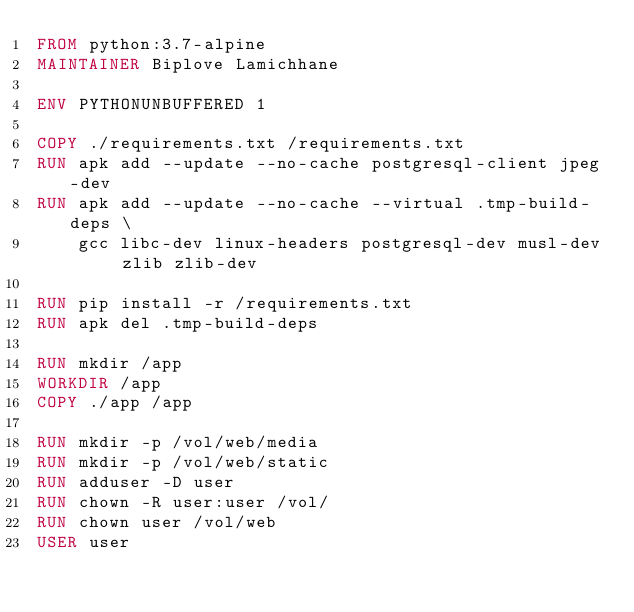<code> <loc_0><loc_0><loc_500><loc_500><_Dockerfile_>FROM python:3.7-alpine
MAINTAINER Biplove Lamichhane

ENV PYTHONUNBUFFERED 1

COPY ./requirements.txt /requirements.txt
RUN apk add --update --no-cache postgresql-client jpeg-dev
RUN apk add --update --no-cache --virtual .tmp-build-deps \
    gcc libc-dev linux-headers postgresql-dev musl-dev zlib zlib-dev

RUN pip install -r /requirements.txt
RUN apk del .tmp-build-deps

RUN mkdir /app
WORKDIR /app
COPY ./app /app

RUN mkdir -p /vol/web/media
RUN mkdir -p /vol/web/static
RUN adduser -D user
RUN chown -R user:user /vol/
RUN chown user /vol/web
USER user</code> 